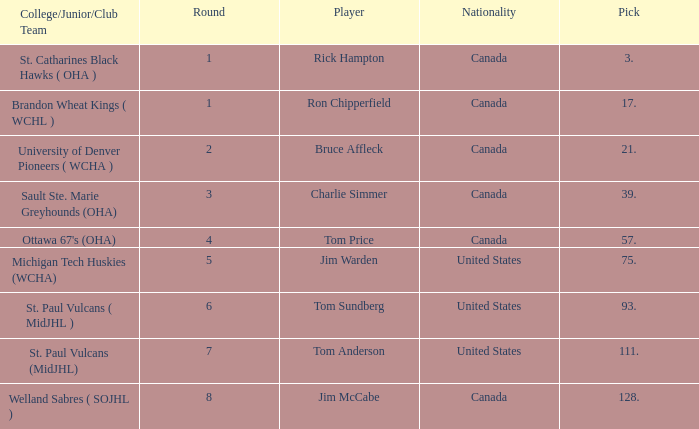Can you tell me the Nationality that has the Round smaller than 5, and the Player of bruce affleck? Canada. 